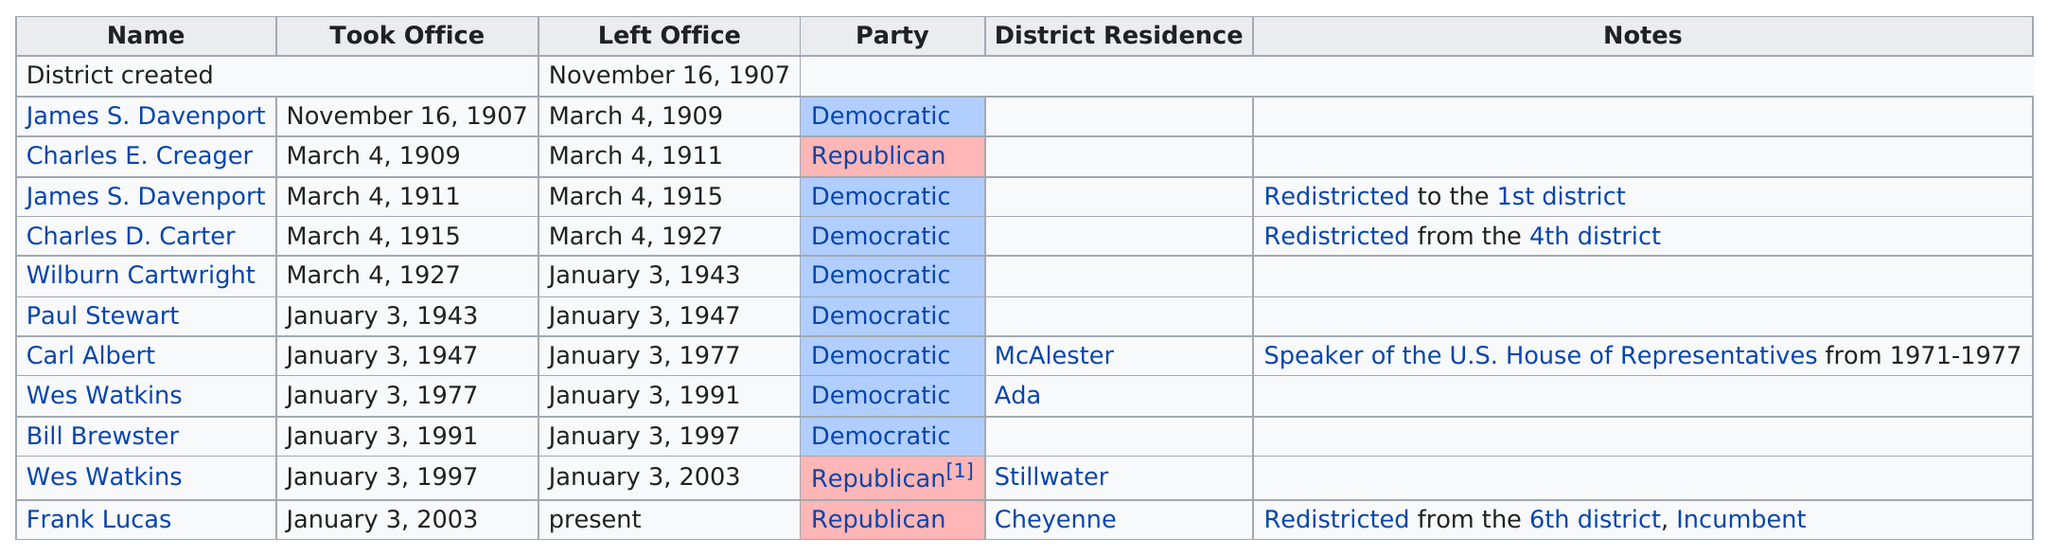Point out several critical features in this image. In the current district, there have been eight past representatives, excluding the current representative. The Democratic party held the most terms in office. Bill Brewster is a Republican. Before Watkins served, how many terms did a Republican serve? The total number of representatives from the Democratic Party is 8. 